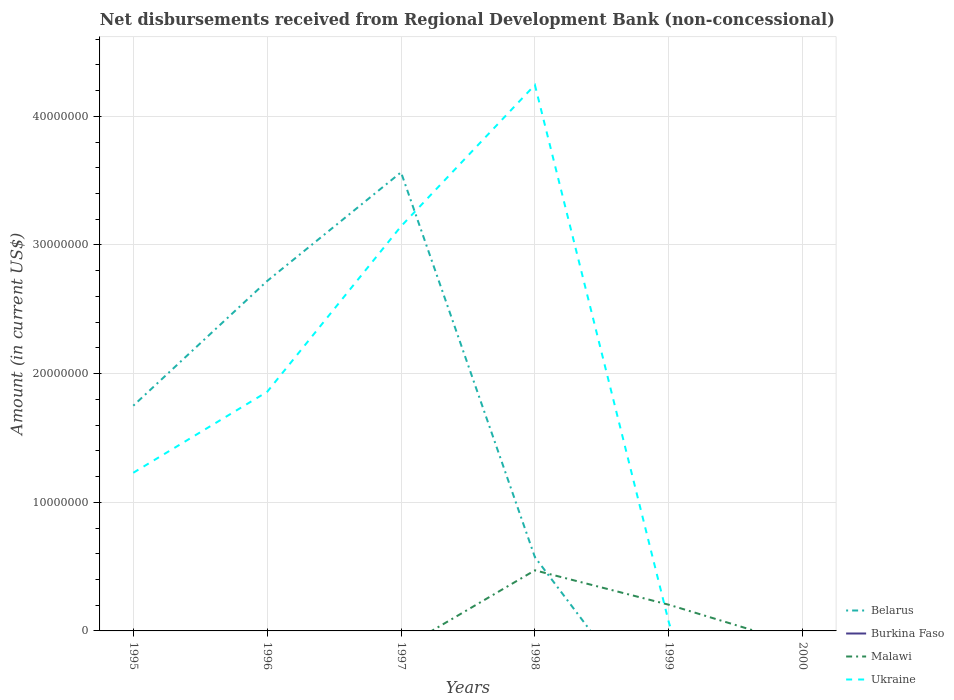How many different coloured lines are there?
Keep it short and to the point. 3. Is the number of lines equal to the number of legend labels?
Your response must be concise. No. What is the total amount of disbursements received from Regional Development Bank in Ukraine in the graph?
Provide a succinct answer. -2.39e+07. What is the difference between the highest and the second highest amount of disbursements received from Regional Development Bank in Malawi?
Your answer should be very brief. 4.71e+06. What is the difference between the highest and the lowest amount of disbursements received from Regional Development Bank in Malawi?
Keep it short and to the point. 2. How many lines are there?
Make the answer very short. 3. Are the values on the major ticks of Y-axis written in scientific E-notation?
Make the answer very short. No. Does the graph contain any zero values?
Make the answer very short. Yes. How many legend labels are there?
Offer a terse response. 4. How are the legend labels stacked?
Offer a very short reply. Vertical. What is the title of the graph?
Keep it short and to the point. Net disbursements received from Regional Development Bank (non-concessional). Does "Russian Federation" appear as one of the legend labels in the graph?
Your answer should be very brief. No. What is the label or title of the X-axis?
Make the answer very short. Years. What is the label or title of the Y-axis?
Your answer should be very brief. Amount (in current US$). What is the Amount (in current US$) of Belarus in 1995?
Give a very brief answer. 1.75e+07. What is the Amount (in current US$) of Burkina Faso in 1995?
Keep it short and to the point. 0. What is the Amount (in current US$) in Malawi in 1995?
Make the answer very short. 0. What is the Amount (in current US$) of Ukraine in 1995?
Offer a terse response. 1.23e+07. What is the Amount (in current US$) in Belarus in 1996?
Offer a very short reply. 2.72e+07. What is the Amount (in current US$) in Ukraine in 1996?
Keep it short and to the point. 1.86e+07. What is the Amount (in current US$) of Belarus in 1997?
Provide a succinct answer. 3.56e+07. What is the Amount (in current US$) in Malawi in 1997?
Offer a terse response. 0. What is the Amount (in current US$) in Ukraine in 1997?
Offer a terse response. 3.15e+07. What is the Amount (in current US$) in Belarus in 1998?
Your answer should be very brief. 5.74e+06. What is the Amount (in current US$) in Malawi in 1998?
Ensure brevity in your answer.  4.71e+06. What is the Amount (in current US$) of Ukraine in 1998?
Your answer should be very brief. 4.24e+07. What is the Amount (in current US$) of Belarus in 1999?
Provide a short and direct response. 0. What is the Amount (in current US$) of Burkina Faso in 1999?
Your response must be concise. 0. What is the Amount (in current US$) in Malawi in 1999?
Provide a short and direct response. 2.04e+06. What is the Amount (in current US$) in Ukraine in 1999?
Your answer should be compact. 6.85e+05. What is the Amount (in current US$) of Belarus in 2000?
Your answer should be very brief. 0. What is the Amount (in current US$) of Burkina Faso in 2000?
Provide a short and direct response. 0. What is the Amount (in current US$) in Malawi in 2000?
Offer a terse response. 0. What is the Amount (in current US$) in Ukraine in 2000?
Offer a terse response. 0. Across all years, what is the maximum Amount (in current US$) of Belarus?
Your answer should be very brief. 3.56e+07. Across all years, what is the maximum Amount (in current US$) of Malawi?
Your answer should be compact. 4.71e+06. Across all years, what is the maximum Amount (in current US$) of Ukraine?
Offer a terse response. 4.24e+07. Across all years, what is the minimum Amount (in current US$) in Belarus?
Provide a short and direct response. 0. What is the total Amount (in current US$) in Belarus in the graph?
Make the answer very short. 8.61e+07. What is the total Amount (in current US$) of Burkina Faso in the graph?
Make the answer very short. 0. What is the total Amount (in current US$) in Malawi in the graph?
Provide a succinct answer. 6.75e+06. What is the total Amount (in current US$) in Ukraine in the graph?
Keep it short and to the point. 1.05e+08. What is the difference between the Amount (in current US$) of Belarus in 1995 and that in 1996?
Provide a short and direct response. -9.69e+06. What is the difference between the Amount (in current US$) in Ukraine in 1995 and that in 1996?
Your response must be concise. -6.29e+06. What is the difference between the Amount (in current US$) in Belarus in 1995 and that in 1997?
Your response must be concise. -1.81e+07. What is the difference between the Amount (in current US$) in Ukraine in 1995 and that in 1997?
Make the answer very short. -1.92e+07. What is the difference between the Amount (in current US$) of Belarus in 1995 and that in 1998?
Your answer should be very brief. 1.18e+07. What is the difference between the Amount (in current US$) of Ukraine in 1995 and that in 1998?
Your answer should be very brief. -3.01e+07. What is the difference between the Amount (in current US$) in Ukraine in 1995 and that in 1999?
Ensure brevity in your answer.  1.16e+07. What is the difference between the Amount (in current US$) of Belarus in 1996 and that in 1997?
Your response must be concise. -8.45e+06. What is the difference between the Amount (in current US$) in Ukraine in 1996 and that in 1997?
Offer a very short reply. -1.29e+07. What is the difference between the Amount (in current US$) of Belarus in 1996 and that in 1998?
Your answer should be very brief. 2.15e+07. What is the difference between the Amount (in current US$) in Ukraine in 1996 and that in 1998?
Ensure brevity in your answer.  -2.39e+07. What is the difference between the Amount (in current US$) in Ukraine in 1996 and that in 1999?
Keep it short and to the point. 1.79e+07. What is the difference between the Amount (in current US$) in Belarus in 1997 and that in 1998?
Your answer should be very brief. 2.99e+07. What is the difference between the Amount (in current US$) of Ukraine in 1997 and that in 1998?
Provide a succinct answer. -1.10e+07. What is the difference between the Amount (in current US$) in Ukraine in 1997 and that in 1999?
Offer a terse response. 3.08e+07. What is the difference between the Amount (in current US$) of Malawi in 1998 and that in 1999?
Your answer should be very brief. 2.67e+06. What is the difference between the Amount (in current US$) in Ukraine in 1998 and that in 1999?
Provide a succinct answer. 4.18e+07. What is the difference between the Amount (in current US$) in Belarus in 1995 and the Amount (in current US$) in Ukraine in 1996?
Provide a short and direct response. -1.08e+06. What is the difference between the Amount (in current US$) of Belarus in 1995 and the Amount (in current US$) of Ukraine in 1997?
Your response must be concise. -1.39e+07. What is the difference between the Amount (in current US$) in Belarus in 1995 and the Amount (in current US$) in Malawi in 1998?
Make the answer very short. 1.28e+07. What is the difference between the Amount (in current US$) of Belarus in 1995 and the Amount (in current US$) of Ukraine in 1998?
Your answer should be very brief. -2.49e+07. What is the difference between the Amount (in current US$) of Belarus in 1995 and the Amount (in current US$) of Malawi in 1999?
Your answer should be very brief. 1.55e+07. What is the difference between the Amount (in current US$) of Belarus in 1995 and the Amount (in current US$) of Ukraine in 1999?
Give a very brief answer. 1.68e+07. What is the difference between the Amount (in current US$) of Belarus in 1996 and the Amount (in current US$) of Ukraine in 1997?
Give a very brief answer. -4.25e+06. What is the difference between the Amount (in current US$) of Belarus in 1996 and the Amount (in current US$) of Malawi in 1998?
Give a very brief answer. 2.25e+07. What is the difference between the Amount (in current US$) in Belarus in 1996 and the Amount (in current US$) in Ukraine in 1998?
Keep it short and to the point. -1.52e+07. What is the difference between the Amount (in current US$) in Belarus in 1996 and the Amount (in current US$) in Malawi in 1999?
Provide a succinct answer. 2.52e+07. What is the difference between the Amount (in current US$) of Belarus in 1996 and the Amount (in current US$) of Ukraine in 1999?
Offer a terse response. 2.65e+07. What is the difference between the Amount (in current US$) of Belarus in 1997 and the Amount (in current US$) of Malawi in 1998?
Ensure brevity in your answer.  3.09e+07. What is the difference between the Amount (in current US$) of Belarus in 1997 and the Amount (in current US$) of Ukraine in 1998?
Offer a terse response. -6.79e+06. What is the difference between the Amount (in current US$) in Belarus in 1997 and the Amount (in current US$) in Malawi in 1999?
Your answer should be very brief. 3.36e+07. What is the difference between the Amount (in current US$) in Belarus in 1997 and the Amount (in current US$) in Ukraine in 1999?
Give a very brief answer. 3.50e+07. What is the difference between the Amount (in current US$) of Belarus in 1998 and the Amount (in current US$) of Malawi in 1999?
Ensure brevity in your answer.  3.70e+06. What is the difference between the Amount (in current US$) in Belarus in 1998 and the Amount (in current US$) in Ukraine in 1999?
Offer a terse response. 5.05e+06. What is the difference between the Amount (in current US$) in Malawi in 1998 and the Amount (in current US$) in Ukraine in 1999?
Offer a terse response. 4.03e+06. What is the average Amount (in current US$) in Belarus per year?
Offer a terse response. 1.43e+07. What is the average Amount (in current US$) in Malawi per year?
Provide a succinct answer. 1.12e+06. What is the average Amount (in current US$) of Ukraine per year?
Your answer should be very brief. 1.76e+07. In the year 1995, what is the difference between the Amount (in current US$) of Belarus and Amount (in current US$) of Ukraine?
Give a very brief answer. 5.21e+06. In the year 1996, what is the difference between the Amount (in current US$) of Belarus and Amount (in current US$) of Ukraine?
Make the answer very short. 8.62e+06. In the year 1997, what is the difference between the Amount (in current US$) of Belarus and Amount (in current US$) of Ukraine?
Provide a succinct answer. 4.20e+06. In the year 1998, what is the difference between the Amount (in current US$) of Belarus and Amount (in current US$) of Malawi?
Keep it short and to the point. 1.02e+06. In the year 1998, what is the difference between the Amount (in current US$) of Belarus and Amount (in current US$) of Ukraine?
Provide a succinct answer. -3.67e+07. In the year 1998, what is the difference between the Amount (in current US$) in Malawi and Amount (in current US$) in Ukraine?
Provide a succinct answer. -3.77e+07. In the year 1999, what is the difference between the Amount (in current US$) in Malawi and Amount (in current US$) in Ukraine?
Keep it short and to the point. 1.35e+06. What is the ratio of the Amount (in current US$) of Belarus in 1995 to that in 1996?
Offer a terse response. 0.64. What is the ratio of the Amount (in current US$) in Ukraine in 1995 to that in 1996?
Keep it short and to the point. 0.66. What is the ratio of the Amount (in current US$) in Belarus in 1995 to that in 1997?
Offer a terse response. 0.49. What is the ratio of the Amount (in current US$) of Ukraine in 1995 to that in 1997?
Provide a short and direct response. 0.39. What is the ratio of the Amount (in current US$) of Belarus in 1995 to that in 1998?
Keep it short and to the point. 3.05. What is the ratio of the Amount (in current US$) in Ukraine in 1995 to that in 1998?
Your answer should be very brief. 0.29. What is the ratio of the Amount (in current US$) in Ukraine in 1995 to that in 1999?
Offer a very short reply. 17.95. What is the ratio of the Amount (in current US$) of Belarus in 1996 to that in 1997?
Offer a very short reply. 0.76. What is the ratio of the Amount (in current US$) of Ukraine in 1996 to that in 1997?
Your answer should be very brief. 0.59. What is the ratio of the Amount (in current US$) of Belarus in 1996 to that in 1998?
Provide a succinct answer. 4.74. What is the ratio of the Amount (in current US$) of Ukraine in 1996 to that in 1998?
Make the answer very short. 0.44. What is the ratio of the Amount (in current US$) in Ukraine in 1996 to that in 1999?
Offer a terse response. 27.13. What is the ratio of the Amount (in current US$) of Belarus in 1997 to that in 1998?
Offer a very short reply. 6.22. What is the ratio of the Amount (in current US$) in Ukraine in 1997 to that in 1998?
Keep it short and to the point. 0.74. What is the ratio of the Amount (in current US$) of Ukraine in 1997 to that in 1999?
Ensure brevity in your answer.  45.92. What is the ratio of the Amount (in current US$) of Malawi in 1998 to that in 1999?
Provide a succinct answer. 2.31. What is the ratio of the Amount (in current US$) in Ukraine in 1998 to that in 1999?
Your response must be concise. 61.96. What is the difference between the highest and the second highest Amount (in current US$) in Belarus?
Keep it short and to the point. 8.45e+06. What is the difference between the highest and the second highest Amount (in current US$) of Ukraine?
Offer a terse response. 1.10e+07. What is the difference between the highest and the lowest Amount (in current US$) in Belarus?
Keep it short and to the point. 3.56e+07. What is the difference between the highest and the lowest Amount (in current US$) of Malawi?
Your answer should be very brief. 4.71e+06. What is the difference between the highest and the lowest Amount (in current US$) of Ukraine?
Keep it short and to the point. 4.24e+07. 